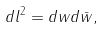<formula> <loc_0><loc_0><loc_500><loc_500>d l ^ { 2 } = d w d \bar { w } ,</formula> 